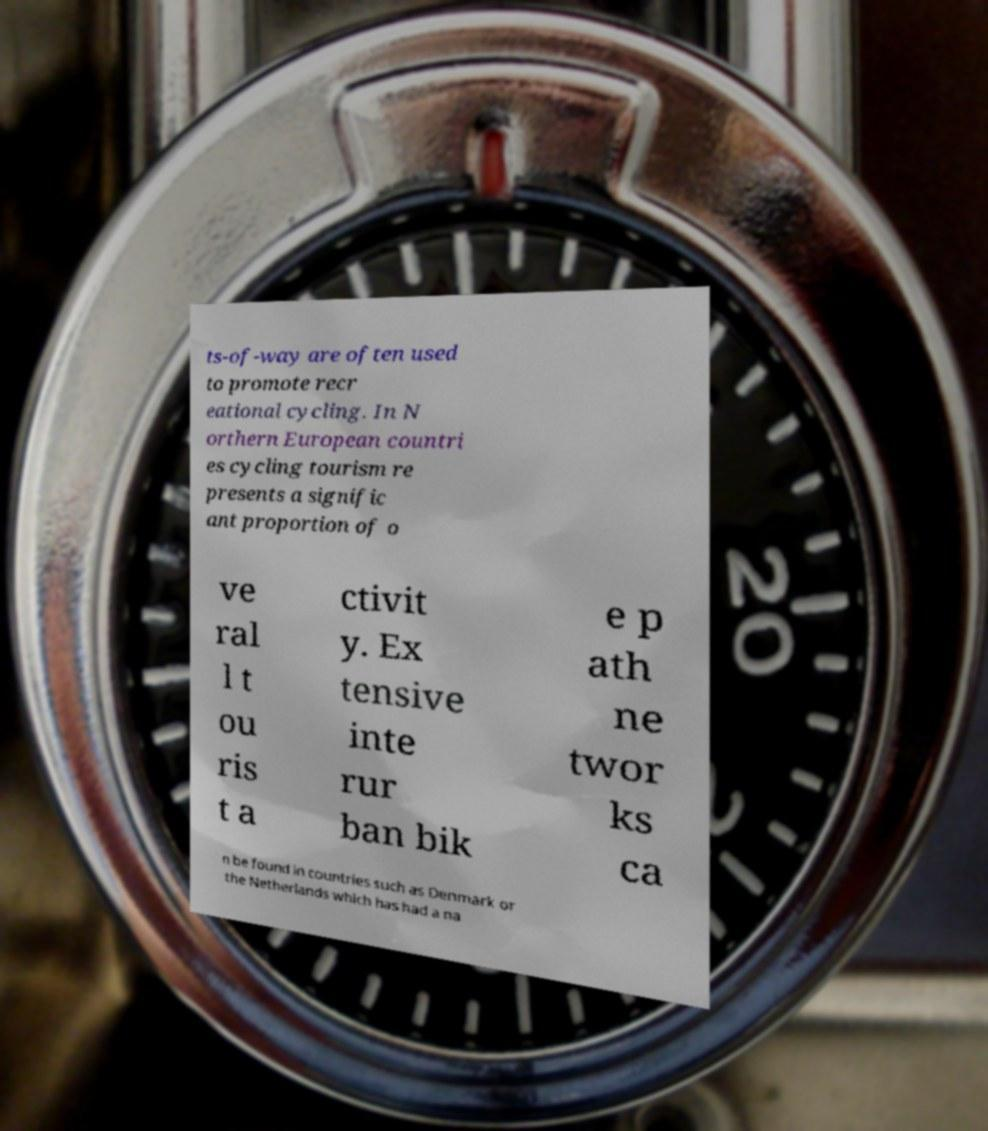Please read and relay the text visible in this image. What does it say? ts-of-way are often used to promote recr eational cycling. In N orthern European countri es cycling tourism re presents a signific ant proportion of o ve ral l t ou ris t a ctivit y. Ex tensive inte rur ban bik e p ath ne twor ks ca n be found in countries such as Denmark or the Netherlands which has had a na 